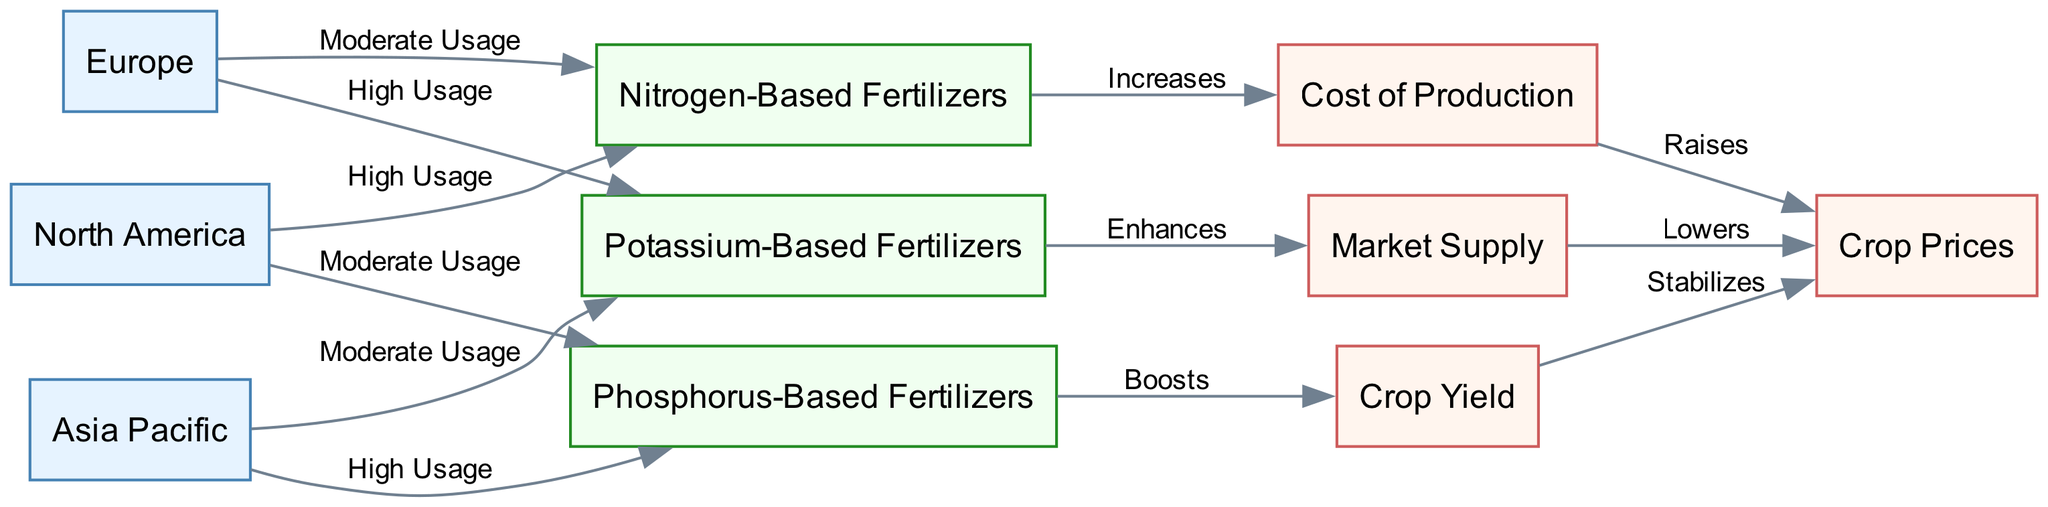What is the nitrogen fertilizer usage in North America? According to the diagram, the label on the edge connecting North America to Nitrogen-Based Fertilizers states "High Usage", indicating that nitrogen fertilizers are used extensively in this region.
Answer: High Usage How many types of fertilizers are represented in the diagram? Counting the nodes for fertilizers, there are three types of fertilizers: Nitrogen-Based, Phosphorus-Based, and Potassium-Based. Therefore, the total count of different fertilizer types is three.
Answer: Three Which economic impact does phosphorus-based fertilizers boost? The edge from Phosphorus-Based Fertilizers to Crop Yield is labeled "Boosts", indicating that phosphorus fertilizers have a positive effect on crop yield specifically.
Answer: Crop Yield What is the effect of potassium-based fertilizers on market supply? The diagram shows that Potassium-Based Fertilizers "Enhances" Market Supply, indicating that the use of this fertilizer positively influences market supply levels.
Answer: Enhances How does the cost of production affect crop prices? The diagram indicates that the Cost of Production "Raises" Crop Prices, meaning that as production costs increase, crop prices also tend to increase.
Answer: Raises What fertilizer type has high usage in Europe? The edge labeled "High Usage" connects Europe to Potassium-Based Fertilizers, indicating that in Europe, potassium fertilizers are applied heavily.
Answer: Potassium-Based Fertilizers What relationship does nitrogen-based fertilizer have with crop prices? The diagram illustrates that the Cost of Production, which increases due to Nitrogen-Based Fertilizers, ultimately leads to higher Crop Prices. This indicates a direct relationship where increased costs from nitrogen fertilizers lead to increased prices for crops.
Answer: Raises Which region uses phosphorus-based fertilizers the most? The diagram shows that Asia Pacific has "High Usage" of Phosphorus-Based Fertilizers, making it the region with the greatest reliance on this type of fertilizer among the represented regions.
Answer: Asia Pacific What is the economic impact of high nitrogen fertilizer usage in North America? The diagram indicates that high usage of Nitrogen-Based Fertilizers in North America contributes positively, "Increases" the Cost of Production, which in turn "Raises" Crop Prices. This sequence illustrates the economic implications of nitrogen use in that region.
Answer: Raises 